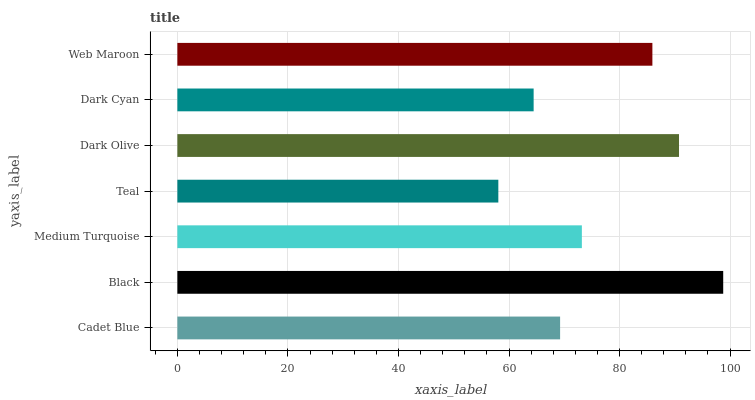Is Teal the minimum?
Answer yes or no. Yes. Is Black the maximum?
Answer yes or no. Yes. Is Medium Turquoise the minimum?
Answer yes or no. No. Is Medium Turquoise the maximum?
Answer yes or no. No. Is Black greater than Medium Turquoise?
Answer yes or no. Yes. Is Medium Turquoise less than Black?
Answer yes or no. Yes. Is Medium Turquoise greater than Black?
Answer yes or no. No. Is Black less than Medium Turquoise?
Answer yes or no. No. Is Medium Turquoise the high median?
Answer yes or no. Yes. Is Medium Turquoise the low median?
Answer yes or no. Yes. Is Black the high median?
Answer yes or no. No. Is Black the low median?
Answer yes or no. No. 